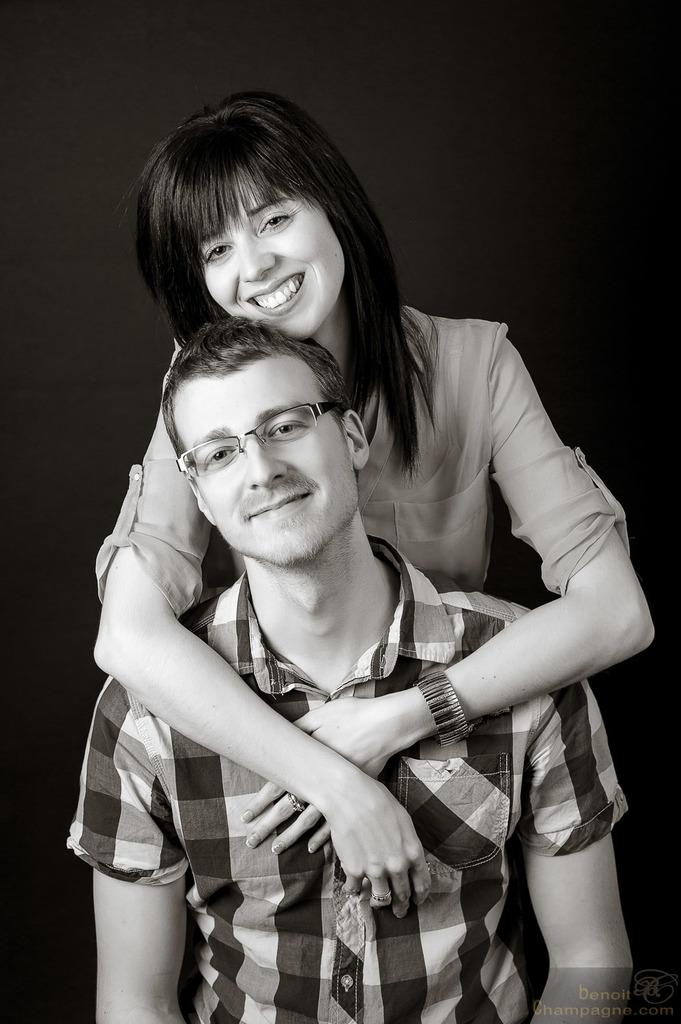What is the person in the image wearing? The person in the image is wearing spectacles and a shirt. What is the woman in the image wearing? The woman in the image is wearing a shirt. How are the person and the woman interacting in the image? The woman has her hands around the person's shoulder. Where is the baby in the image? There is no baby present in the image. What type of underwear is the person wearing in the image? The provided facts do not mention any underwear, so we cannot determine what type the person is wearing. 